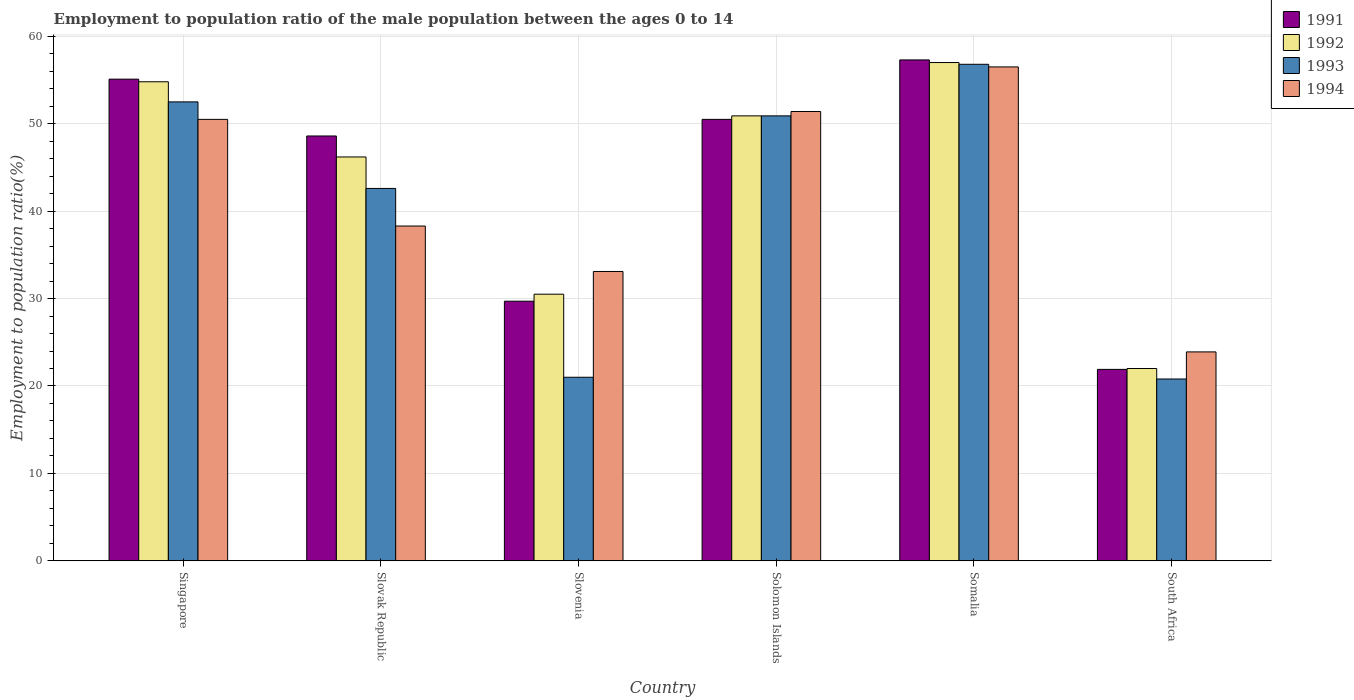How many groups of bars are there?
Offer a terse response. 6. Are the number of bars on each tick of the X-axis equal?
Provide a short and direct response. Yes. How many bars are there on the 2nd tick from the right?
Give a very brief answer. 4. What is the label of the 3rd group of bars from the left?
Offer a very short reply. Slovenia. In how many cases, is the number of bars for a given country not equal to the number of legend labels?
Keep it short and to the point. 0. What is the employment to population ratio in 1993 in Slovak Republic?
Your answer should be very brief. 42.6. Across all countries, what is the maximum employment to population ratio in 1994?
Ensure brevity in your answer.  56.5. Across all countries, what is the minimum employment to population ratio in 1993?
Ensure brevity in your answer.  20.8. In which country was the employment to population ratio in 1992 maximum?
Offer a terse response. Somalia. In which country was the employment to population ratio in 1991 minimum?
Offer a very short reply. South Africa. What is the total employment to population ratio in 1991 in the graph?
Your response must be concise. 263.1. What is the difference between the employment to population ratio in 1993 in Solomon Islands and that in South Africa?
Offer a very short reply. 30.1. What is the difference between the employment to population ratio in 1991 in Slovak Republic and the employment to population ratio in 1992 in Solomon Islands?
Provide a succinct answer. -2.3. What is the average employment to population ratio in 1993 per country?
Give a very brief answer. 40.77. What is the difference between the employment to population ratio of/in 1991 and employment to population ratio of/in 1992 in Singapore?
Offer a very short reply. 0.3. In how many countries, is the employment to population ratio in 1992 greater than 44 %?
Make the answer very short. 4. What is the ratio of the employment to population ratio in 1992 in Somalia to that in South Africa?
Keep it short and to the point. 2.59. Is the difference between the employment to population ratio in 1991 in Slovak Republic and South Africa greater than the difference between the employment to population ratio in 1992 in Slovak Republic and South Africa?
Your response must be concise. Yes. What is the difference between the highest and the second highest employment to population ratio in 1992?
Keep it short and to the point. 6.1. In how many countries, is the employment to population ratio in 1994 greater than the average employment to population ratio in 1994 taken over all countries?
Offer a very short reply. 3. Is it the case that in every country, the sum of the employment to population ratio in 1993 and employment to population ratio in 1991 is greater than the sum of employment to population ratio in 1994 and employment to population ratio in 1992?
Make the answer very short. No. What does the 4th bar from the left in Solomon Islands represents?
Your answer should be compact. 1994. How many countries are there in the graph?
Provide a short and direct response. 6. Are the values on the major ticks of Y-axis written in scientific E-notation?
Your response must be concise. No. Does the graph contain any zero values?
Provide a short and direct response. No. Does the graph contain grids?
Offer a very short reply. Yes. Where does the legend appear in the graph?
Your answer should be compact. Top right. How many legend labels are there?
Your answer should be very brief. 4. How are the legend labels stacked?
Provide a short and direct response. Vertical. What is the title of the graph?
Make the answer very short. Employment to population ratio of the male population between the ages 0 to 14. What is the Employment to population ratio(%) in 1991 in Singapore?
Your answer should be very brief. 55.1. What is the Employment to population ratio(%) in 1992 in Singapore?
Provide a succinct answer. 54.8. What is the Employment to population ratio(%) of 1993 in Singapore?
Provide a succinct answer. 52.5. What is the Employment to population ratio(%) in 1994 in Singapore?
Provide a short and direct response. 50.5. What is the Employment to population ratio(%) of 1991 in Slovak Republic?
Offer a very short reply. 48.6. What is the Employment to population ratio(%) in 1992 in Slovak Republic?
Keep it short and to the point. 46.2. What is the Employment to population ratio(%) in 1993 in Slovak Republic?
Make the answer very short. 42.6. What is the Employment to population ratio(%) of 1994 in Slovak Republic?
Your answer should be compact. 38.3. What is the Employment to population ratio(%) in 1991 in Slovenia?
Give a very brief answer. 29.7. What is the Employment to population ratio(%) in 1992 in Slovenia?
Keep it short and to the point. 30.5. What is the Employment to population ratio(%) in 1993 in Slovenia?
Make the answer very short. 21. What is the Employment to population ratio(%) of 1994 in Slovenia?
Offer a terse response. 33.1. What is the Employment to population ratio(%) in 1991 in Solomon Islands?
Your answer should be compact. 50.5. What is the Employment to population ratio(%) in 1992 in Solomon Islands?
Ensure brevity in your answer.  50.9. What is the Employment to population ratio(%) of 1993 in Solomon Islands?
Provide a succinct answer. 50.9. What is the Employment to population ratio(%) in 1994 in Solomon Islands?
Your answer should be compact. 51.4. What is the Employment to population ratio(%) of 1991 in Somalia?
Give a very brief answer. 57.3. What is the Employment to population ratio(%) in 1993 in Somalia?
Provide a succinct answer. 56.8. What is the Employment to population ratio(%) in 1994 in Somalia?
Make the answer very short. 56.5. What is the Employment to population ratio(%) in 1991 in South Africa?
Ensure brevity in your answer.  21.9. What is the Employment to population ratio(%) in 1992 in South Africa?
Your response must be concise. 22. What is the Employment to population ratio(%) in 1993 in South Africa?
Your answer should be compact. 20.8. What is the Employment to population ratio(%) of 1994 in South Africa?
Offer a very short reply. 23.9. Across all countries, what is the maximum Employment to population ratio(%) in 1991?
Offer a very short reply. 57.3. Across all countries, what is the maximum Employment to population ratio(%) in 1992?
Your answer should be very brief. 57. Across all countries, what is the maximum Employment to population ratio(%) of 1993?
Your answer should be compact. 56.8. Across all countries, what is the maximum Employment to population ratio(%) of 1994?
Keep it short and to the point. 56.5. Across all countries, what is the minimum Employment to population ratio(%) in 1991?
Offer a terse response. 21.9. Across all countries, what is the minimum Employment to population ratio(%) of 1993?
Your answer should be very brief. 20.8. Across all countries, what is the minimum Employment to population ratio(%) in 1994?
Offer a very short reply. 23.9. What is the total Employment to population ratio(%) of 1991 in the graph?
Make the answer very short. 263.1. What is the total Employment to population ratio(%) in 1992 in the graph?
Keep it short and to the point. 261.4. What is the total Employment to population ratio(%) of 1993 in the graph?
Offer a very short reply. 244.6. What is the total Employment to population ratio(%) in 1994 in the graph?
Make the answer very short. 253.7. What is the difference between the Employment to population ratio(%) of 1991 in Singapore and that in Slovenia?
Offer a very short reply. 25.4. What is the difference between the Employment to population ratio(%) in 1992 in Singapore and that in Slovenia?
Keep it short and to the point. 24.3. What is the difference between the Employment to population ratio(%) of 1993 in Singapore and that in Slovenia?
Give a very brief answer. 31.5. What is the difference between the Employment to population ratio(%) in 1994 in Singapore and that in Slovenia?
Your answer should be compact. 17.4. What is the difference between the Employment to population ratio(%) in 1991 in Singapore and that in Solomon Islands?
Offer a terse response. 4.6. What is the difference between the Employment to population ratio(%) of 1993 in Singapore and that in Solomon Islands?
Provide a succinct answer. 1.6. What is the difference between the Employment to population ratio(%) of 1991 in Singapore and that in South Africa?
Give a very brief answer. 33.2. What is the difference between the Employment to population ratio(%) of 1992 in Singapore and that in South Africa?
Your answer should be very brief. 32.8. What is the difference between the Employment to population ratio(%) in 1993 in Singapore and that in South Africa?
Give a very brief answer. 31.7. What is the difference between the Employment to population ratio(%) of 1994 in Singapore and that in South Africa?
Make the answer very short. 26.6. What is the difference between the Employment to population ratio(%) in 1992 in Slovak Republic and that in Slovenia?
Give a very brief answer. 15.7. What is the difference between the Employment to population ratio(%) of 1993 in Slovak Republic and that in Slovenia?
Make the answer very short. 21.6. What is the difference between the Employment to population ratio(%) of 1994 in Slovak Republic and that in Slovenia?
Ensure brevity in your answer.  5.2. What is the difference between the Employment to population ratio(%) of 1991 in Slovak Republic and that in Solomon Islands?
Provide a succinct answer. -1.9. What is the difference between the Employment to population ratio(%) in 1994 in Slovak Republic and that in Solomon Islands?
Your answer should be compact. -13.1. What is the difference between the Employment to population ratio(%) in 1991 in Slovak Republic and that in Somalia?
Your answer should be very brief. -8.7. What is the difference between the Employment to population ratio(%) in 1993 in Slovak Republic and that in Somalia?
Offer a very short reply. -14.2. What is the difference between the Employment to population ratio(%) in 1994 in Slovak Republic and that in Somalia?
Your answer should be very brief. -18.2. What is the difference between the Employment to population ratio(%) of 1991 in Slovak Republic and that in South Africa?
Provide a short and direct response. 26.7. What is the difference between the Employment to population ratio(%) of 1992 in Slovak Republic and that in South Africa?
Your answer should be compact. 24.2. What is the difference between the Employment to population ratio(%) of 1993 in Slovak Republic and that in South Africa?
Give a very brief answer. 21.8. What is the difference between the Employment to population ratio(%) in 1994 in Slovak Republic and that in South Africa?
Give a very brief answer. 14.4. What is the difference between the Employment to population ratio(%) in 1991 in Slovenia and that in Solomon Islands?
Keep it short and to the point. -20.8. What is the difference between the Employment to population ratio(%) in 1992 in Slovenia and that in Solomon Islands?
Your answer should be very brief. -20.4. What is the difference between the Employment to population ratio(%) in 1993 in Slovenia and that in Solomon Islands?
Your response must be concise. -29.9. What is the difference between the Employment to population ratio(%) in 1994 in Slovenia and that in Solomon Islands?
Keep it short and to the point. -18.3. What is the difference between the Employment to population ratio(%) of 1991 in Slovenia and that in Somalia?
Your response must be concise. -27.6. What is the difference between the Employment to population ratio(%) of 1992 in Slovenia and that in Somalia?
Provide a short and direct response. -26.5. What is the difference between the Employment to population ratio(%) in 1993 in Slovenia and that in Somalia?
Make the answer very short. -35.8. What is the difference between the Employment to population ratio(%) of 1994 in Slovenia and that in Somalia?
Offer a terse response. -23.4. What is the difference between the Employment to population ratio(%) in 1992 in Slovenia and that in South Africa?
Keep it short and to the point. 8.5. What is the difference between the Employment to population ratio(%) of 1994 in Slovenia and that in South Africa?
Ensure brevity in your answer.  9.2. What is the difference between the Employment to population ratio(%) in 1994 in Solomon Islands and that in Somalia?
Provide a short and direct response. -5.1. What is the difference between the Employment to population ratio(%) in 1991 in Solomon Islands and that in South Africa?
Your answer should be compact. 28.6. What is the difference between the Employment to population ratio(%) in 1992 in Solomon Islands and that in South Africa?
Keep it short and to the point. 28.9. What is the difference between the Employment to population ratio(%) in 1993 in Solomon Islands and that in South Africa?
Offer a very short reply. 30.1. What is the difference between the Employment to population ratio(%) of 1991 in Somalia and that in South Africa?
Provide a short and direct response. 35.4. What is the difference between the Employment to population ratio(%) of 1992 in Somalia and that in South Africa?
Ensure brevity in your answer.  35. What is the difference between the Employment to population ratio(%) of 1994 in Somalia and that in South Africa?
Provide a succinct answer. 32.6. What is the difference between the Employment to population ratio(%) of 1991 in Singapore and the Employment to population ratio(%) of 1992 in Slovak Republic?
Offer a very short reply. 8.9. What is the difference between the Employment to population ratio(%) in 1991 in Singapore and the Employment to population ratio(%) in 1993 in Slovak Republic?
Give a very brief answer. 12.5. What is the difference between the Employment to population ratio(%) in 1992 in Singapore and the Employment to population ratio(%) in 1994 in Slovak Republic?
Your response must be concise. 16.5. What is the difference between the Employment to population ratio(%) of 1993 in Singapore and the Employment to population ratio(%) of 1994 in Slovak Republic?
Your answer should be compact. 14.2. What is the difference between the Employment to population ratio(%) of 1991 in Singapore and the Employment to population ratio(%) of 1992 in Slovenia?
Offer a very short reply. 24.6. What is the difference between the Employment to population ratio(%) in 1991 in Singapore and the Employment to population ratio(%) in 1993 in Slovenia?
Offer a terse response. 34.1. What is the difference between the Employment to population ratio(%) in 1992 in Singapore and the Employment to population ratio(%) in 1993 in Slovenia?
Your answer should be compact. 33.8. What is the difference between the Employment to population ratio(%) of 1992 in Singapore and the Employment to population ratio(%) of 1994 in Slovenia?
Your answer should be very brief. 21.7. What is the difference between the Employment to population ratio(%) in 1991 in Singapore and the Employment to population ratio(%) in 1992 in Solomon Islands?
Provide a succinct answer. 4.2. What is the difference between the Employment to population ratio(%) in 1992 in Singapore and the Employment to population ratio(%) in 1993 in Solomon Islands?
Provide a short and direct response. 3.9. What is the difference between the Employment to population ratio(%) of 1993 in Singapore and the Employment to population ratio(%) of 1994 in Solomon Islands?
Make the answer very short. 1.1. What is the difference between the Employment to population ratio(%) in 1991 in Singapore and the Employment to population ratio(%) in 1992 in Somalia?
Your answer should be very brief. -1.9. What is the difference between the Employment to population ratio(%) of 1991 in Singapore and the Employment to population ratio(%) of 1993 in Somalia?
Keep it short and to the point. -1.7. What is the difference between the Employment to population ratio(%) in 1991 in Singapore and the Employment to population ratio(%) in 1994 in Somalia?
Keep it short and to the point. -1.4. What is the difference between the Employment to population ratio(%) of 1992 in Singapore and the Employment to population ratio(%) of 1993 in Somalia?
Your answer should be compact. -2. What is the difference between the Employment to population ratio(%) of 1993 in Singapore and the Employment to population ratio(%) of 1994 in Somalia?
Ensure brevity in your answer.  -4. What is the difference between the Employment to population ratio(%) of 1991 in Singapore and the Employment to population ratio(%) of 1992 in South Africa?
Make the answer very short. 33.1. What is the difference between the Employment to population ratio(%) in 1991 in Singapore and the Employment to population ratio(%) in 1993 in South Africa?
Provide a short and direct response. 34.3. What is the difference between the Employment to population ratio(%) of 1991 in Singapore and the Employment to population ratio(%) of 1994 in South Africa?
Provide a short and direct response. 31.2. What is the difference between the Employment to population ratio(%) in 1992 in Singapore and the Employment to population ratio(%) in 1994 in South Africa?
Your answer should be very brief. 30.9. What is the difference between the Employment to population ratio(%) of 1993 in Singapore and the Employment to population ratio(%) of 1994 in South Africa?
Give a very brief answer. 28.6. What is the difference between the Employment to population ratio(%) in 1991 in Slovak Republic and the Employment to population ratio(%) in 1993 in Slovenia?
Offer a very short reply. 27.6. What is the difference between the Employment to population ratio(%) of 1991 in Slovak Republic and the Employment to population ratio(%) of 1994 in Slovenia?
Keep it short and to the point. 15.5. What is the difference between the Employment to population ratio(%) of 1992 in Slovak Republic and the Employment to population ratio(%) of 1993 in Slovenia?
Your answer should be very brief. 25.2. What is the difference between the Employment to population ratio(%) in 1992 in Slovak Republic and the Employment to population ratio(%) in 1994 in Slovenia?
Offer a very short reply. 13.1. What is the difference between the Employment to population ratio(%) in 1991 in Slovak Republic and the Employment to population ratio(%) in 1992 in Solomon Islands?
Your answer should be compact. -2.3. What is the difference between the Employment to population ratio(%) of 1991 in Slovak Republic and the Employment to population ratio(%) of 1993 in Solomon Islands?
Ensure brevity in your answer.  -2.3. What is the difference between the Employment to population ratio(%) in 1992 in Slovak Republic and the Employment to population ratio(%) in 1993 in Solomon Islands?
Your answer should be very brief. -4.7. What is the difference between the Employment to population ratio(%) of 1992 in Slovak Republic and the Employment to population ratio(%) of 1994 in Solomon Islands?
Make the answer very short. -5.2. What is the difference between the Employment to population ratio(%) of 1993 in Slovak Republic and the Employment to population ratio(%) of 1994 in Solomon Islands?
Make the answer very short. -8.8. What is the difference between the Employment to population ratio(%) of 1991 in Slovak Republic and the Employment to population ratio(%) of 1994 in Somalia?
Your response must be concise. -7.9. What is the difference between the Employment to population ratio(%) in 1992 in Slovak Republic and the Employment to population ratio(%) in 1994 in Somalia?
Provide a short and direct response. -10.3. What is the difference between the Employment to population ratio(%) of 1993 in Slovak Republic and the Employment to population ratio(%) of 1994 in Somalia?
Provide a short and direct response. -13.9. What is the difference between the Employment to population ratio(%) in 1991 in Slovak Republic and the Employment to population ratio(%) in 1992 in South Africa?
Your answer should be very brief. 26.6. What is the difference between the Employment to population ratio(%) in 1991 in Slovak Republic and the Employment to population ratio(%) in 1993 in South Africa?
Your answer should be very brief. 27.8. What is the difference between the Employment to population ratio(%) of 1991 in Slovak Republic and the Employment to population ratio(%) of 1994 in South Africa?
Offer a very short reply. 24.7. What is the difference between the Employment to population ratio(%) of 1992 in Slovak Republic and the Employment to population ratio(%) of 1993 in South Africa?
Provide a short and direct response. 25.4. What is the difference between the Employment to population ratio(%) in 1992 in Slovak Republic and the Employment to population ratio(%) in 1994 in South Africa?
Ensure brevity in your answer.  22.3. What is the difference between the Employment to population ratio(%) in 1993 in Slovak Republic and the Employment to population ratio(%) in 1994 in South Africa?
Your answer should be compact. 18.7. What is the difference between the Employment to population ratio(%) in 1991 in Slovenia and the Employment to population ratio(%) in 1992 in Solomon Islands?
Offer a very short reply. -21.2. What is the difference between the Employment to population ratio(%) in 1991 in Slovenia and the Employment to population ratio(%) in 1993 in Solomon Islands?
Make the answer very short. -21.2. What is the difference between the Employment to population ratio(%) in 1991 in Slovenia and the Employment to population ratio(%) in 1994 in Solomon Islands?
Your answer should be very brief. -21.7. What is the difference between the Employment to population ratio(%) of 1992 in Slovenia and the Employment to population ratio(%) of 1993 in Solomon Islands?
Your answer should be very brief. -20.4. What is the difference between the Employment to population ratio(%) in 1992 in Slovenia and the Employment to population ratio(%) in 1994 in Solomon Islands?
Offer a very short reply. -20.9. What is the difference between the Employment to population ratio(%) of 1993 in Slovenia and the Employment to population ratio(%) of 1994 in Solomon Islands?
Make the answer very short. -30.4. What is the difference between the Employment to population ratio(%) in 1991 in Slovenia and the Employment to population ratio(%) in 1992 in Somalia?
Your answer should be compact. -27.3. What is the difference between the Employment to population ratio(%) in 1991 in Slovenia and the Employment to population ratio(%) in 1993 in Somalia?
Offer a terse response. -27.1. What is the difference between the Employment to population ratio(%) of 1991 in Slovenia and the Employment to population ratio(%) of 1994 in Somalia?
Make the answer very short. -26.8. What is the difference between the Employment to population ratio(%) in 1992 in Slovenia and the Employment to population ratio(%) in 1993 in Somalia?
Ensure brevity in your answer.  -26.3. What is the difference between the Employment to population ratio(%) in 1993 in Slovenia and the Employment to population ratio(%) in 1994 in Somalia?
Your answer should be compact. -35.5. What is the difference between the Employment to population ratio(%) of 1991 in Slovenia and the Employment to population ratio(%) of 1992 in South Africa?
Your answer should be very brief. 7.7. What is the difference between the Employment to population ratio(%) in 1991 in Slovenia and the Employment to population ratio(%) in 1993 in South Africa?
Make the answer very short. 8.9. What is the difference between the Employment to population ratio(%) in 1992 in Slovenia and the Employment to population ratio(%) in 1994 in South Africa?
Your answer should be very brief. 6.6. What is the difference between the Employment to population ratio(%) of 1993 in Slovenia and the Employment to population ratio(%) of 1994 in South Africa?
Make the answer very short. -2.9. What is the difference between the Employment to population ratio(%) in 1991 in Solomon Islands and the Employment to population ratio(%) in 1993 in Somalia?
Your answer should be compact. -6.3. What is the difference between the Employment to population ratio(%) in 1991 in Solomon Islands and the Employment to population ratio(%) in 1994 in Somalia?
Provide a short and direct response. -6. What is the difference between the Employment to population ratio(%) of 1992 in Solomon Islands and the Employment to population ratio(%) of 1994 in Somalia?
Offer a terse response. -5.6. What is the difference between the Employment to population ratio(%) in 1993 in Solomon Islands and the Employment to population ratio(%) in 1994 in Somalia?
Provide a succinct answer. -5.6. What is the difference between the Employment to population ratio(%) of 1991 in Solomon Islands and the Employment to population ratio(%) of 1993 in South Africa?
Provide a succinct answer. 29.7. What is the difference between the Employment to population ratio(%) of 1991 in Solomon Islands and the Employment to population ratio(%) of 1994 in South Africa?
Provide a succinct answer. 26.6. What is the difference between the Employment to population ratio(%) of 1992 in Solomon Islands and the Employment to population ratio(%) of 1993 in South Africa?
Offer a very short reply. 30.1. What is the difference between the Employment to population ratio(%) in 1991 in Somalia and the Employment to population ratio(%) in 1992 in South Africa?
Provide a succinct answer. 35.3. What is the difference between the Employment to population ratio(%) in 1991 in Somalia and the Employment to population ratio(%) in 1993 in South Africa?
Offer a terse response. 36.5. What is the difference between the Employment to population ratio(%) of 1991 in Somalia and the Employment to population ratio(%) of 1994 in South Africa?
Keep it short and to the point. 33.4. What is the difference between the Employment to population ratio(%) in 1992 in Somalia and the Employment to population ratio(%) in 1993 in South Africa?
Make the answer very short. 36.2. What is the difference between the Employment to population ratio(%) in 1992 in Somalia and the Employment to population ratio(%) in 1994 in South Africa?
Your answer should be compact. 33.1. What is the difference between the Employment to population ratio(%) in 1993 in Somalia and the Employment to population ratio(%) in 1994 in South Africa?
Give a very brief answer. 32.9. What is the average Employment to population ratio(%) of 1991 per country?
Your response must be concise. 43.85. What is the average Employment to population ratio(%) in 1992 per country?
Make the answer very short. 43.57. What is the average Employment to population ratio(%) of 1993 per country?
Keep it short and to the point. 40.77. What is the average Employment to population ratio(%) in 1994 per country?
Make the answer very short. 42.28. What is the difference between the Employment to population ratio(%) of 1991 and Employment to population ratio(%) of 1994 in Singapore?
Offer a terse response. 4.6. What is the difference between the Employment to population ratio(%) of 1992 and Employment to population ratio(%) of 1993 in Singapore?
Give a very brief answer. 2.3. What is the difference between the Employment to population ratio(%) of 1991 and Employment to population ratio(%) of 1992 in Slovak Republic?
Ensure brevity in your answer.  2.4. What is the difference between the Employment to population ratio(%) of 1991 and Employment to population ratio(%) of 1994 in Slovak Republic?
Ensure brevity in your answer.  10.3. What is the difference between the Employment to population ratio(%) in 1992 and Employment to population ratio(%) in 1993 in Slovak Republic?
Provide a succinct answer. 3.6. What is the difference between the Employment to population ratio(%) of 1992 and Employment to population ratio(%) of 1994 in Slovak Republic?
Your answer should be compact. 7.9. What is the difference between the Employment to population ratio(%) of 1991 and Employment to population ratio(%) of 1992 in Slovenia?
Give a very brief answer. -0.8. What is the difference between the Employment to population ratio(%) of 1992 and Employment to population ratio(%) of 1994 in Slovenia?
Your response must be concise. -2.6. What is the difference between the Employment to population ratio(%) in 1993 and Employment to population ratio(%) in 1994 in Solomon Islands?
Your answer should be compact. -0.5. What is the difference between the Employment to population ratio(%) of 1991 and Employment to population ratio(%) of 1992 in Somalia?
Provide a succinct answer. 0.3. What is the difference between the Employment to population ratio(%) in 1991 and Employment to population ratio(%) in 1994 in Somalia?
Give a very brief answer. 0.8. What is the difference between the Employment to population ratio(%) of 1992 and Employment to population ratio(%) of 1993 in Somalia?
Your response must be concise. 0.2. What is the difference between the Employment to population ratio(%) of 1992 and Employment to population ratio(%) of 1994 in Somalia?
Offer a terse response. 0.5. What is the difference between the Employment to population ratio(%) of 1991 and Employment to population ratio(%) of 1992 in South Africa?
Give a very brief answer. -0.1. What is the difference between the Employment to population ratio(%) in 1991 and Employment to population ratio(%) in 1993 in South Africa?
Provide a succinct answer. 1.1. What is the difference between the Employment to population ratio(%) of 1991 and Employment to population ratio(%) of 1994 in South Africa?
Offer a terse response. -2. What is the difference between the Employment to population ratio(%) in 1992 and Employment to population ratio(%) in 1994 in South Africa?
Keep it short and to the point. -1.9. What is the ratio of the Employment to population ratio(%) in 1991 in Singapore to that in Slovak Republic?
Your answer should be very brief. 1.13. What is the ratio of the Employment to population ratio(%) of 1992 in Singapore to that in Slovak Republic?
Provide a short and direct response. 1.19. What is the ratio of the Employment to population ratio(%) in 1993 in Singapore to that in Slovak Republic?
Give a very brief answer. 1.23. What is the ratio of the Employment to population ratio(%) in 1994 in Singapore to that in Slovak Republic?
Make the answer very short. 1.32. What is the ratio of the Employment to population ratio(%) of 1991 in Singapore to that in Slovenia?
Give a very brief answer. 1.86. What is the ratio of the Employment to population ratio(%) of 1992 in Singapore to that in Slovenia?
Provide a succinct answer. 1.8. What is the ratio of the Employment to population ratio(%) of 1993 in Singapore to that in Slovenia?
Offer a very short reply. 2.5. What is the ratio of the Employment to population ratio(%) in 1994 in Singapore to that in Slovenia?
Keep it short and to the point. 1.53. What is the ratio of the Employment to population ratio(%) of 1991 in Singapore to that in Solomon Islands?
Your answer should be very brief. 1.09. What is the ratio of the Employment to population ratio(%) in 1992 in Singapore to that in Solomon Islands?
Give a very brief answer. 1.08. What is the ratio of the Employment to population ratio(%) in 1993 in Singapore to that in Solomon Islands?
Offer a terse response. 1.03. What is the ratio of the Employment to population ratio(%) of 1994 in Singapore to that in Solomon Islands?
Provide a short and direct response. 0.98. What is the ratio of the Employment to population ratio(%) in 1991 in Singapore to that in Somalia?
Give a very brief answer. 0.96. What is the ratio of the Employment to population ratio(%) in 1992 in Singapore to that in Somalia?
Ensure brevity in your answer.  0.96. What is the ratio of the Employment to population ratio(%) in 1993 in Singapore to that in Somalia?
Give a very brief answer. 0.92. What is the ratio of the Employment to population ratio(%) in 1994 in Singapore to that in Somalia?
Offer a very short reply. 0.89. What is the ratio of the Employment to population ratio(%) of 1991 in Singapore to that in South Africa?
Provide a short and direct response. 2.52. What is the ratio of the Employment to population ratio(%) in 1992 in Singapore to that in South Africa?
Keep it short and to the point. 2.49. What is the ratio of the Employment to population ratio(%) of 1993 in Singapore to that in South Africa?
Offer a very short reply. 2.52. What is the ratio of the Employment to population ratio(%) in 1994 in Singapore to that in South Africa?
Give a very brief answer. 2.11. What is the ratio of the Employment to population ratio(%) of 1991 in Slovak Republic to that in Slovenia?
Provide a short and direct response. 1.64. What is the ratio of the Employment to population ratio(%) of 1992 in Slovak Republic to that in Slovenia?
Keep it short and to the point. 1.51. What is the ratio of the Employment to population ratio(%) in 1993 in Slovak Republic to that in Slovenia?
Ensure brevity in your answer.  2.03. What is the ratio of the Employment to population ratio(%) of 1994 in Slovak Republic to that in Slovenia?
Offer a terse response. 1.16. What is the ratio of the Employment to population ratio(%) of 1991 in Slovak Republic to that in Solomon Islands?
Your answer should be very brief. 0.96. What is the ratio of the Employment to population ratio(%) in 1992 in Slovak Republic to that in Solomon Islands?
Ensure brevity in your answer.  0.91. What is the ratio of the Employment to population ratio(%) in 1993 in Slovak Republic to that in Solomon Islands?
Offer a very short reply. 0.84. What is the ratio of the Employment to population ratio(%) of 1994 in Slovak Republic to that in Solomon Islands?
Offer a terse response. 0.75. What is the ratio of the Employment to population ratio(%) in 1991 in Slovak Republic to that in Somalia?
Keep it short and to the point. 0.85. What is the ratio of the Employment to population ratio(%) of 1992 in Slovak Republic to that in Somalia?
Provide a short and direct response. 0.81. What is the ratio of the Employment to population ratio(%) of 1994 in Slovak Republic to that in Somalia?
Ensure brevity in your answer.  0.68. What is the ratio of the Employment to population ratio(%) in 1991 in Slovak Republic to that in South Africa?
Provide a short and direct response. 2.22. What is the ratio of the Employment to population ratio(%) in 1993 in Slovak Republic to that in South Africa?
Your answer should be compact. 2.05. What is the ratio of the Employment to population ratio(%) of 1994 in Slovak Republic to that in South Africa?
Offer a very short reply. 1.6. What is the ratio of the Employment to population ratio(%) of 1991 in Slovenia to that in Solomon Islands?
Your answer should be very brief. 0.59. What is the ratio of the Employment to population ratio(%) of 1992 in Slovenia to that in Solomon Islands?
Make the answer very short. 0.6. What is the ratio of the Employment to population ratio(%) of 1993 in Slovenia to that in Solomon Islands?
Offer a very short reply. 0.41. What is the ratio of the Employment to population ratio(%) in 1994 in Slovenia to that in Solomon Islands?
Provide a succinct answer. 0.64. What is the ratio of the Employment to population ratio(%) in 1991 in Slovenia to that in Somalia?
Your answer should be compact. 0.52. What is the ratio of the Employment to population ratio(%) in 1992 in Slovenia to that in Somalia?
Offer a terse response. 0.54. What is the ratio of the Employment to population ratio(%) of 1993 in Slovenia to that in Somalia?
Your answer should be compact. 0.37. What is the ratio of the Employment to population ratio(%) of 1994 in Slovenia to that in Somalia?
Your answer should be compact. 0.59. What is the ratio of the Employment to population ratio(%) in 1991 in Slovenia to that in South Africa?
Offer a very short reply. 1.36. What is the ratio of the Employment to population ratio(%) of 1992 in Slovenia to that in South Africa?
Ensure brevity in your answer.  1.39. What is the ratio of the Employment to population ratio(%) of 1993 in Slovenia to that in South Africa?
Ensure brevity in your answer.  1.01. What is the ratio of the Employment to population ratio(%) of 1994 in Slovenia to that in South Africa?
Keep it short and to the point. 1.38. What is the ratio of the Employment to population ratio(%) in 1991 in Solomon Islands to that in Somalia?
Your answer should be very brief. 0.88. What is the ratio of the Employment to population ratio(%) in 1992 in Solomon Islands to that in Somalia?
Provide a short and direct response. 0.89. What is the ratio of the Employment to population ratio(%) of 1993 in Solomon Islands to that in Somalia?
Provide a succinct answer. 0.9. What is the ratio of the Employment to population ratio(%) in 1994 in Solomon Islands to that in Somalia?
Offer a very short reply. 0.91. What is the ratio of the Employment to population ratio(%) of 1991 in Solomon Islands to that in South Africa?
Give a very brief answer. 2.31. What is the ratio of the Employment to population ratio(%) in 1992 in Solomon Islands to that in South Africa?
Provide a short and direct response. 2.31. What is the ratio of the Employment to population ratio(%) of 1993 in Solomon Islands to that in South Africa?
Ensure brevity in your answer.  2.45. What is the ratio of the Employment to population ratio(%) of 1994 in Solomon Islands to that in South Africa?
Ensure brevity in your answer.  2.15. What is the ratio of the Employment to population ratio(%) in 1991 in Somalia to that in South Africa?
Your response must be concise. 2.62. What is the ratio of the Employment to population ratio(%) of 1992 in Somalia to that in South Africa?
Your answer should be compact. 2.59. What is the ratio of the Employment to population ratio(%) in 1993 in Somalia to that in South Africa?
Provide a succinct answer. 2.73. What is the ratio of the Employment to population ratio(%) in 1994 in Somalia to that in South Africa?
Your response must be concise. 2.36. What is the difference between the highest and the second highest Employment to population ratio(%) in 1991?
Your answer should be compact. 2.2. What is the difference between the highest and the second highest Employment to population ratio(%) in 1992?
Offer a very short reply. 2.2. What is the difference between the highest and the second highest Employment to population ratio(%) in 1994?
Make the answer very short. 5.1. What is the difference between the highest and the lowest Employment to population ratio(%) in 1991?
Make the answer very short. 35.4. What is the difference between the highest and the lowest Employment to population ratio(%) of 1994?
Your answer should be compact. 32.6. 